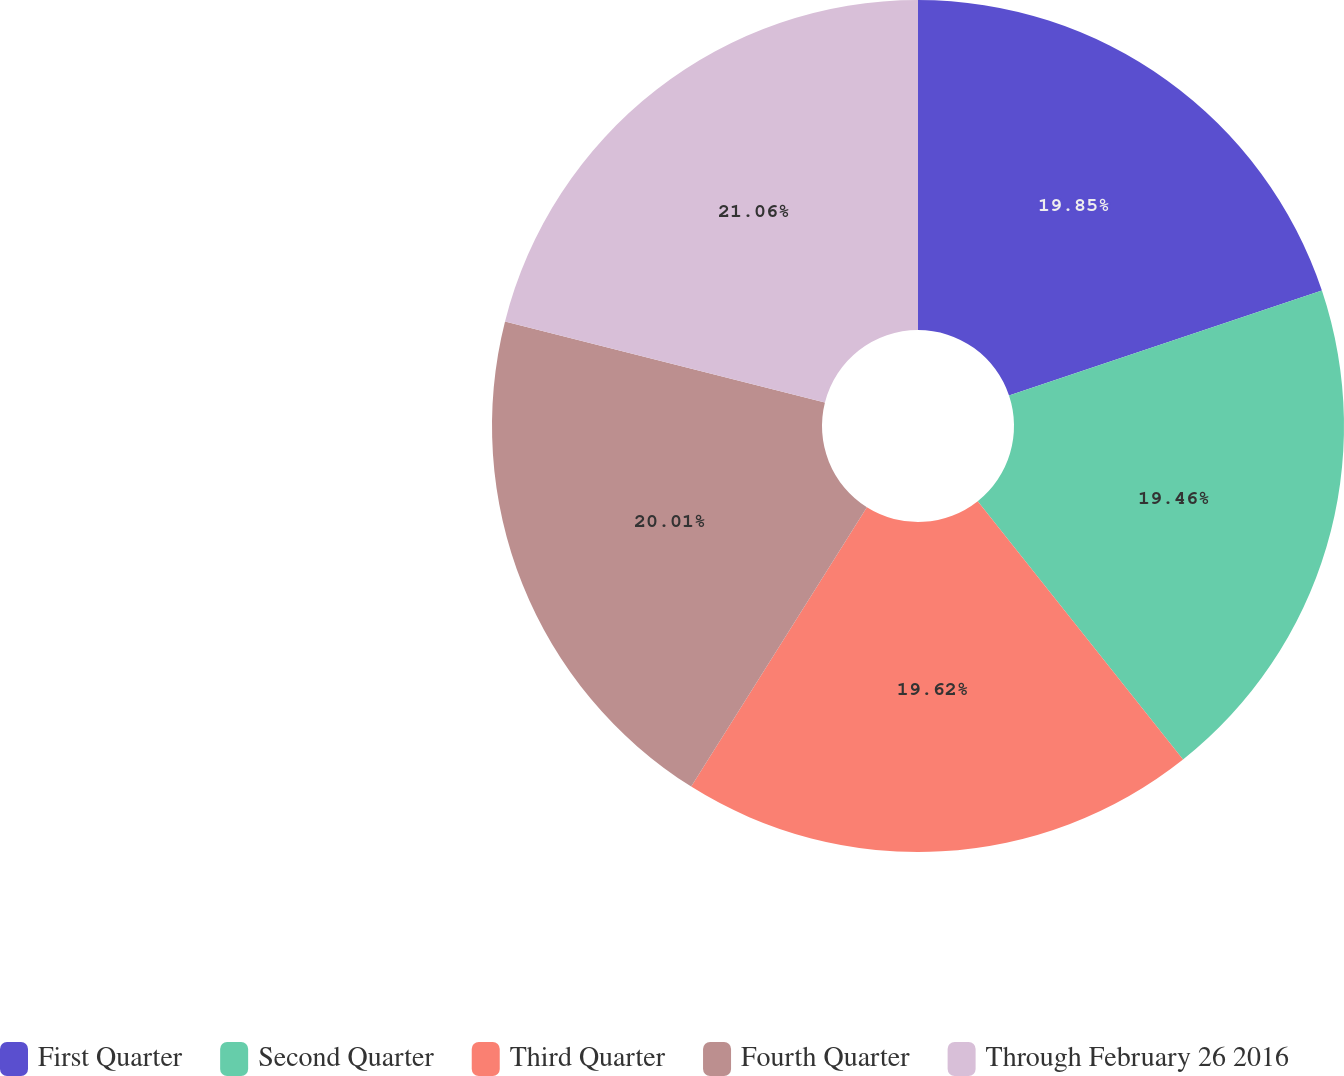<chart> <loc_0><loc_0><loc_500><loc_500><pie_chart><fcel>First Quarter<fcel>Second Quarter<fcel>Third Quarter<fcel>Fourth Quarter<fcel>Through February 26 2016<nl><fcel>19.85%<fcel>19.46%<fcel>19.62%<fcel>20.01%<fcel>21.05%<nl></chart> 